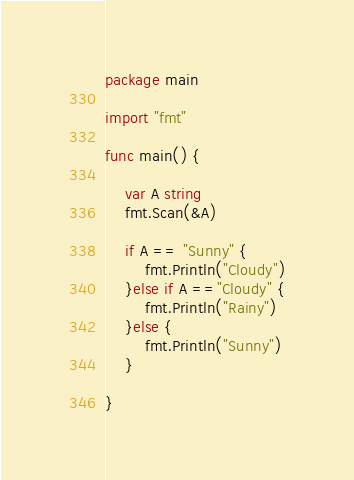Convert code to text. <code><loc_0><loc_0><loc_500><loc_500><_Go_>package main

import "fmt"

func main() {

	var A string
	fmt.Scan(&A)

	if A == "Sunny" {
		fmt.Println("Cloudy")
	}else if A =="Cloudy" {
		fmt.Println("Rainy")
	}else {
		fmt.Println("Sunny")
	}
	
}
</code> 